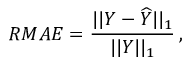Convert formula to latex. <formula><loc_0><loc_0><loc_500><loc_500>R M A E = \frac { | | Y - \widehat { Y } | | _ { 1 } } { | | Y | | _ { 1 } } \, ,</formula> 